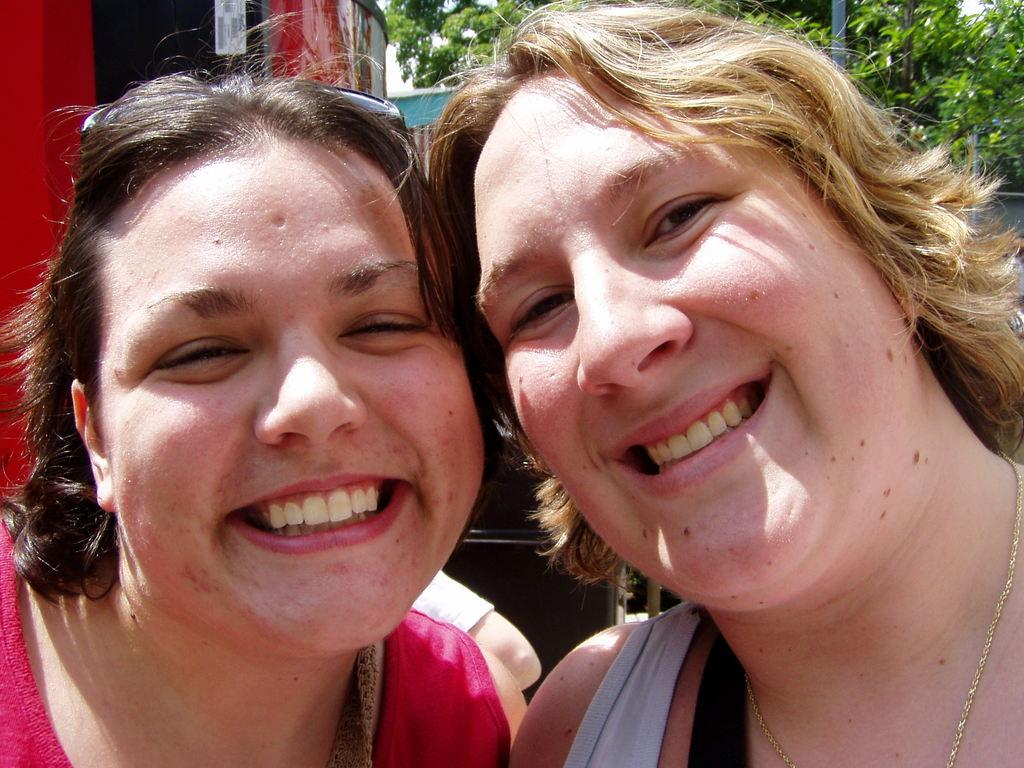How many people are in the image? There are two women in the image. What is the facial expression of the women? The women are smiling. What can be seen in the background of the image? Trees are visible at the top of the image. What type of needle can be seen in the hands of the women in the image? There are no needles present in the image; the women are not holding any objects. How many planes are flying in the sky in the image? There are no planes visible in the image; only trees are present in the background. 